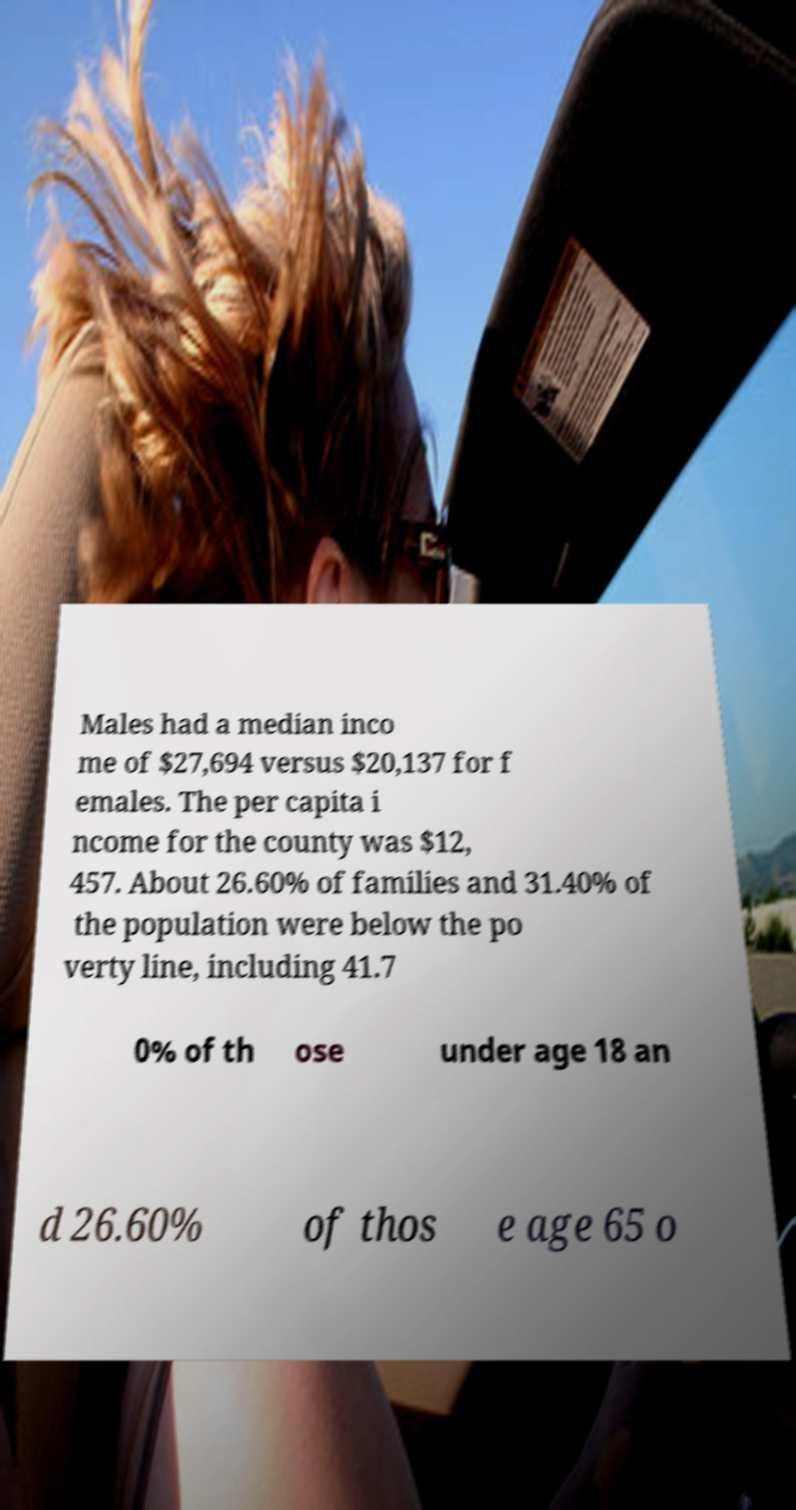I need the written content from this picture converted into text. Can you do that? Males had a median inco me of $27,694 versus $20,137 for f emales. The per capita i ncome for the county was $12, 457. About 26.60% of families and 31.40% of the population were below the po verty line, including 41.7 0% of th ose under age 18 an d 26.60% of thos e age 65 o 